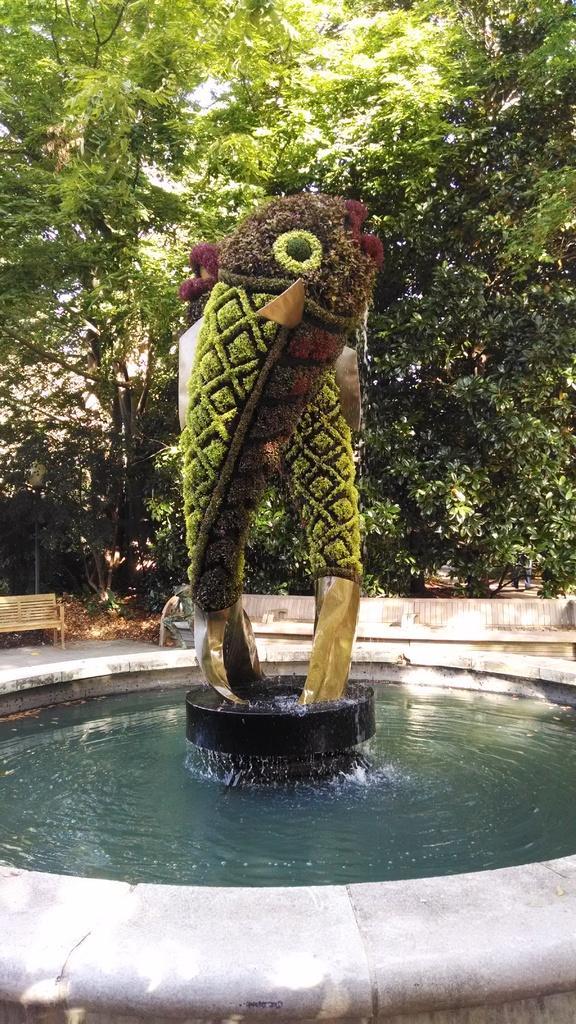Please provide a concise description of this image. In this image I can see the water, the fountain and few trees which are in the shape of fish. In the background I can see few trees which are green in color and few benches. 